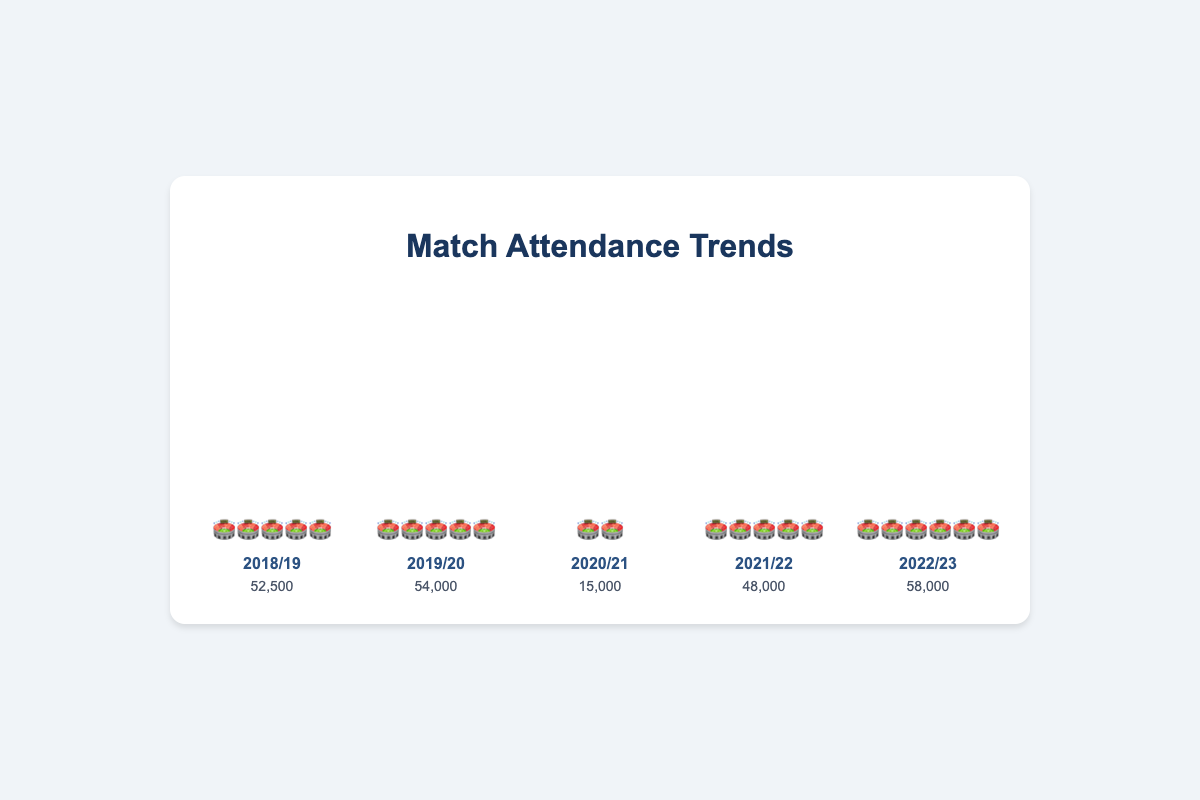What is the average attendance for the 2018/19 season? The title of the chart indicates it shows match attendance trends over multiple seasons. The bar labeled "2018/19" shows an emoji stack of 5 stadiums and an average attendance of 52,500.
Answer: 52,500 Which season had the highest average attendance? From the visual information, the bar for the 2022/23 season has the tallest emoji stack with 6 stadiums, indicating the highest average attendance of 58,000.
Answer: 2022/23 How much did the average attendance drop from 2019/20 to 2020/21? The average attendance for 2019/20 was 54,000, and for 2020/21 it was 15,000. The attendance drop is calculated by subtracting 15,000 from 54,000.
Answer: 39,000 What is the total number of stadium emojis used in the chart? Adding the number of stadium emojis for each season (5 + 5 + 2 + 5 + 6), we get the total number of emojis.
Answer: 23 Which season showed a recovery in attendance after the 2020/21 drop? The data shows a decrease in the 2020/21 season followed by an increase in the 2021/22 season as indicated by the taller emoji stack (from 2 stadiums to 5 stadiums).
Answer: 2021/22 How does the average attendance in 2022/23 compare to 2021/22? Comparing the emoji stacks, 2022/23 has 6 stadiums while 2021/22 has 5, indicating an increase from 48,000 to 58,000.
Answer: Increased What is the overall trend in match attendance over the five seasons? Analyzing the emoji stacks: there is an increase from 5 (2018/19) to 5 (2019/20), a sharp drop to 2 in 2020/21, followed by recovery to 5 in 2021/22, and further increase to 6 in 2022/23, indicating fluctuating trends with a recent increase.
Answer: Fluctuating with a recent increase 